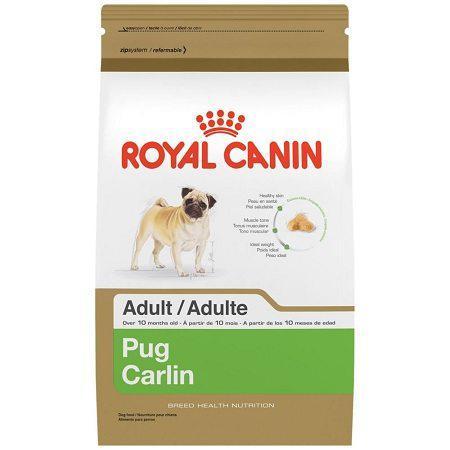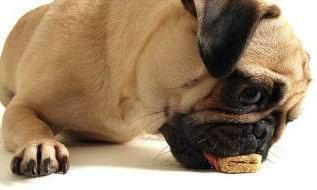The first image is the image on the left, the second image is the image on the right. Assess this claim about the two images: "An image shows one pug dog with one pet food bowl.". Correct or not? Answer yes or no. No. 